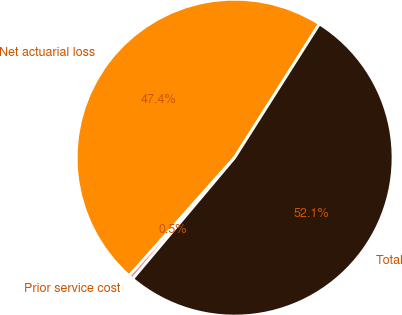Convert chart. <chart><loc_0><loc_0><loc_500><loc_500><pie_chart><fcel>Net actuarial loss<fcel>Prior service cost<fcel>Total<nl><fcel>47.4%<fcel>0.46%<fcel>52.14%<nl></chart> 